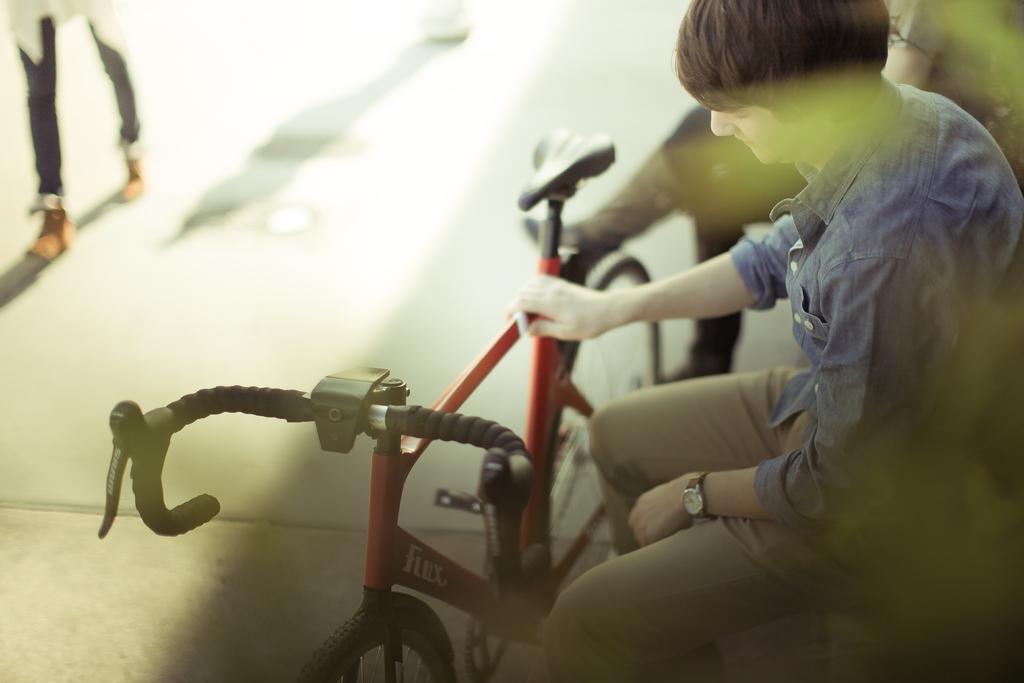How would you summarize this image in a sentence or two? In this picture there are two people sitting and we can see bicycle on the ground. In the background of the image we can see person's legs. 